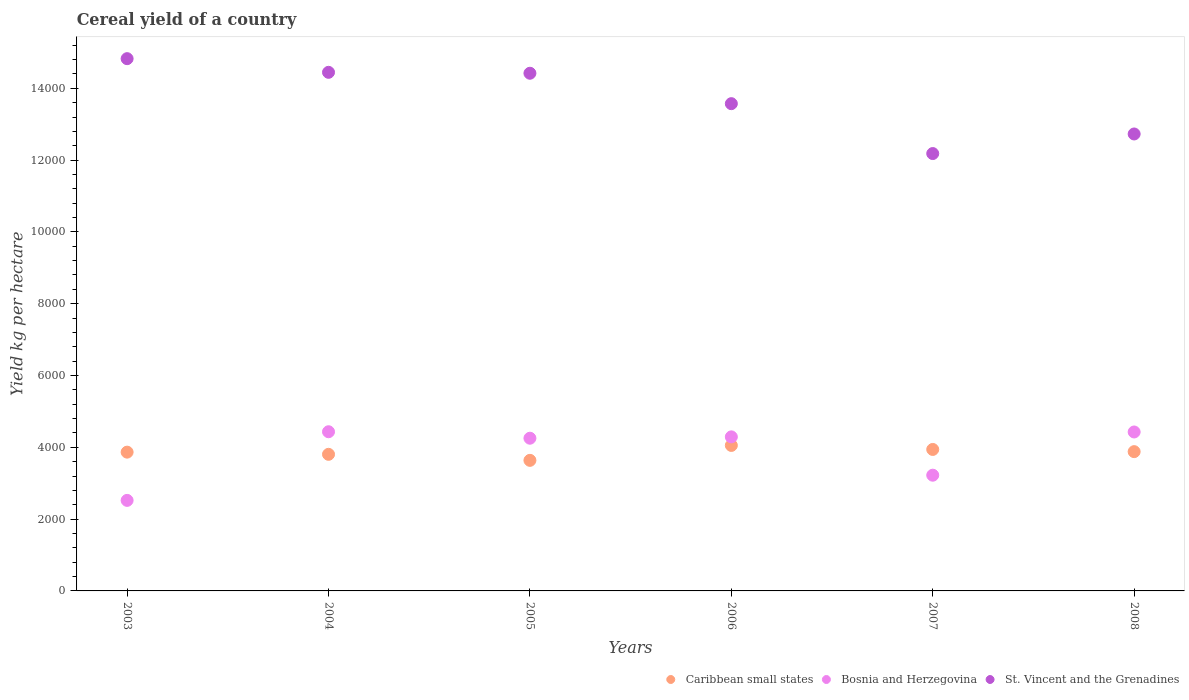How many different coloured dotlines are there?
Give a very brief answer. 3. Is the number of dotlines equal to the number of legend labels?
Make the answer very short. Yes. What is the total cereal yield in Bosnia and Herzegovina in 2006?
Ensure brevity in your answer.  4290.81. Across all years, what is the maximum total cereal yield in Bosnia and Herzegovina?
Your response must be concise. 4433.55. Across all years, what is the minimum total cereal yield in St. Vincent and the Grenadines?
Ensure brevity in your answer.  1.22e+04. In which year was the total cereal yield in St. Vincent and the Grenadines maximum?
Your response must be concise. 2003. In which year was the total cereal yield in St. Vincent and the Grenadines minimum?
Make the answer very short. 2007. What is the total total cereal yield in Caribbean small states in the graph?
Keep it short and to the point. 2.32e+04. What is the difference between the total cereal yield in Caribbean small states in 2005 and that in 2006?
Your response must be concise. -415.91. What is the difference between the total cereal yield in Bosnia and Herzegovina in 2006 and the total cereal yield in St. Vincent and the Grenadines in 2004?
Offer a very short reply. -1.02e+04. What is the average total cereal yield in St. Vincent and the Grenadines per year?
Provide a succinct answer. 1.37e+04. In the year 2003, what is the difference between the total cereal yield in Bosnia and Herzegovina and total cereal yield in St. Vincent and the Grenadines?
Offer a terse response. -1.23e+04. What is the ratio of the total cereal yield in Bosnia and Herzegovina in 2003 to that in 2006?
Your answer should be compact. 0.59. Is the total cereal yield in Bosnia and Herzegovina in 2007 less than that in 2008?
Make the answer very short. Yes. Is the difference between the total cereal yield in Bosnia and Herzegovina in 2005 and 2008 greater than the difference between the total cereal yield in St. Vincent and the Grenadines in 2005 and 2008?
Your answer should be very brief. No. What is the difference between the highest and the second highest total cereal yield in St. Vincent and the Grenadines?
Offer a terse response. 380.56. What is the difference between the highest and the lowest total cereal yield in Bosnia and Herzegovina?
Provide a succinct answer. 1911.92. In how many years, is the total cereal yield in Caribbean small states greater than the average total cereal yield in Caribbean small states taken over all years?
Provide a short and direct response. 4. Is the total cereal yield in Bosnia and Herzegovina strictly less than the total cereal yield in Caribbean small states over the years?
Your answer should be compact. No. How many dotlines are there?
Your response must be concise. 3. How many years are there in the graph?
Provide a succinct answer. 6. Does the graph contain grids?
Offer a very short reply. No. How are the legend labels stacked?
Your response must be concise. Horizontal. What is the title of the graph?
Your answer should be compact. Cereal yield of a country. What is the label or title of the Y-axis?
Offer a very short reply. Yield kg per hectare. What is the Yield kg per hectare of Caribbean small states in 2003?
Make the answer very short. 3865.45. What is the Yield kg per hectare in Bosnia and Herzegovina in 2003?
Provide a short and direct response. 2521.63. What is the Yield kg per hectare in St. Vincent and the Grenadines in 2003?
Your answer should be very brief. 1.48e+04. What is the Yield kg per hectare of Caribbean small states in 2004?
Provide a short and direct response. 3804.68. What is the Yield kg per hectare in Bosnia and Herzegovina in 2004?
Keep it short and to the point. 4433.55. What is the Yield kg per hectare of St. Vincent and the Grenadines in 2004?
Provide a succinct answer. 1.44e+04. What is the Yield kg per hectare of Caribbean small states in 2005?
Give a very brief answer. 3636.67. What is the Yield kg per hectare in Bosnia and Herzegovina in 2005?
Provide a short and direct response. 4253.26. What is the Yield kg per hectare in St. Vincent and the Grenadines in 2005?
Your answer should be very brief. 1.44e+04. What is the Yield kg per hectare in Caribbean small states in 2006?
Offer a terse response. 4052.57. What is the Yield kg per hectare in Bosnia and Herzegovina in 2006?
Your answer should be very brief. 4290.81. What is the Yield kg per hectare in St. Vincent and the Grenadines in 2006?
Give a very brief answer. 1.36e+04. What is the Yield kg per hectare of Caribbean small states in 2007?
Offer a terse response. 3940.38. What is the Yield kg per hectare of Bosnia and Herzegovina in 2007?
Your response must be concise. 3223.22. What is the Yield kg per hectare of St. Vincent and the Grenadines in 2007?
Offer a very short reply. 1.22e+04. What is the Yield kg per hectare in Caribbean small states in 2008?
Give a very brief answer. 3879.35. What is the Yield kg per hectare in Bosnia and Herzegovina in 2008?
Ensure brevity in your answer.  4427.09. What is the Yield kg per hectare of St. Vincent and the Grenadines in 2008?
Give a very brief answer. 1.27e+04. Across all years, what is the maximum Yield kg per hectare of Caribbean small states?
Your answer should be very brief. 4052.57. Across all years, what is the maximum Yield kg per hectare in Bosnia and Herzegovina?
Your response must be concise. 4433.55. Across all years, what is the maximum Yield kg per hectare of St. Vincent and the Grenadines?
Ensure brevity in your answer.  1.48e+04. Across all years, what is the minimum Yield kg per hectare of Caribbean small states?
Ensure brevity in your answer.  3636.67. Across all years, what is the minimum Yield kg per hectare of Bosnia and Herzegovina?
Provide a short and direct response. 2521.63. Across all years, what is the minimum Yield kg per hectare in St. Vincent and the Grenadines?
Make the answer very short. 1.22e+04. What is the total Yield kg per hectare in Caribbean small states in the graph?
Offer a terse response. 2.32e+04. What is the total Yield kg per hectare in Bosnia and Herzegovina in the graph?
Your answer should be compact. 2.31e+04. What is the total Yield kg per hectare of St. Vincent and the Grenadines in the graph?
Make the answer very short. 8.22e+04. What is the difference between the Yield kg per hectare in Caribbean small states in 2003 and that in 2004?
Give a very brief answer. 60.77. What is the difference between the Yield kg per hectare in Bosnia and Herzegovina in 2003 and that in 2004?
Make the answer very short. -1911.92. What is the difference between the Yield kg per hectare in St. Vincent and the Grenadines in 2003 and that in 2004?
Your response must be concise. 380.56. What is the difference between the Yield kg per hectare of Caribbean small states in 2003 and that in 2005?
Your response must be concise. 228.78. What is the difference between the Yield kg per hectare of Bosnia and Herzegovina in 2003 and that in 2005?
Your answer should be very brief. -1731.63. What is the difference between the Yield kg per hectare in St. Vincent and the Grenadines in 2003 and that in 2005?
Ensure brevity in your answer.  406.39. What is the difference between the Yield kg per hectare in Caribbean small states in 2003 and that in 2006?
Keep it short and to the point. -187.13. What is the difference between the Yield kg per hectare of Bosnia and Herzegovina in 2003 and that in 2006?
Keep it short and to the point. -1769.19. What is the difference between the Yield kg per hectare of St. Vincent and the Grenadines in 2003 and that in 2006?
Your answer should be very brief. 1253.57. What is the difference between the Yield kg per hectare in Caribbean small states in 2003 and that in 2007?
Give a very brief answer. -74.93. What is the difference between the Yield kg per hectare of Bosnia and Herzegovina in 2003 and that in 2007?
Give a very brief answer. -701.6. What is the difference between the Yield kg per hectare in St. Vincent and the Grenadines in 2003 and that in 2007?
Your response must be concise. 2643.18. What is the difference between the Yield kg per hectare in Caribbean small states in 2003 and that in 2008?
Keep it short and to the point. -13.91. What is the difference between the Yield kg per hectare in Bosnia and Herzegovina in 2003 and that in 2008?
Offer a terse response. -1905.47. What is the difference between the Yield kg per hectare of St. Vincent and the Grenadines in 2003 and that in 2008?
Your response must be concise. 2097.73. What is the difference between the Yield kg per hectare in Caribbean small states in 2004 and that in 2005?
Your answer should be compact. 168.01. What is the difference between the Yield kg per hectare of Bosnia and Herzegovina in 2004 and that in 2005?
Provide a succinct answer. 180.29. What is the difference between the Yield kg per hectare in St. Vincent and the Grenadines in 2004 and that in 2005?
Make the answer very short. 25.84. What is the difference between the Yield kg per hectare in Caribbean small states in 2004 and that in 2006?
Your response must be concise. -247.89. What is the difference between the Yield kg per hectare of Bosnia and Herzegovina in 2004 and that in 2006?
Your response must be concise. 142.74. What is the difference between the Yield kg per hectare of St. Vincent and the Grenadines in 2004 and that in 2006?
Keep it short and to the point. 873.01. What is the difference between the Yield kg per hectare of Caribbean small states in 2004 and that in 2007?
Offer a terse response. -135.7. What is the difference between the Yield kg per hectare in Bosnia and Herzegovina in 2004 and that in 2007?
Provide a short and direct response. 1210.32. What is the difference between the Yield kg per hectare of St. Vincent and the Grenadines in 2004 and that in 2007?
Your answer should be very brief. 2262.63. What is the difference between the Yield kg per hectare of Caribbean small states in 2004 and that in 2008?
Provide a short and direct response. -74.67. What is the difference between the Yield kg per hectare of Bosnia and Herzegovina in 2004 and that in 2008?
Provide a succinct answer. 6.46. What is the difference between the Yield kg per hectare in St. Vincent and the Grenadines in 2004 and that in 2008?
Give a very brief answer. 1717.17. What is the difference between the Yield kg per hectare in Caribbean small states in 2005 and that in 2006?
Give a very brief answer. -415.91. What is the difference between the Yield kg per hectare in Bosnia and Herzegovina in 2005 and that in 2006?
Give a very brief answer. -37.55. What is the difference between the Yield kg per hectare in St. Vincent and the Grenadines in 2005 and that in 2006?
Offer a very short reply. 847.18. What is the difference between the Yield kg per hectare in Caribbean small states in 2005 and that in 2007?
Provide a short and direct response. -303.71. What is the difference between the Yield kg per hectare of Bosnia and Herzegovina in 2005 and that in 2007?
Ensure brevity in your answer.  1030.04. What is the difference between the Yield kg per hectare of St. Vincent and the Grenadines in 2005 and that in 2007?
Offer a very short reply. 2236.79. What is the difference between the Yield kg per hectare of Caribbean small states in 2005 and that in 2008?
Your answer should be compact. -242.69. What is the difference between the Yield kg per hectare in Bosnia and Herzegovina in 2005 and that in 2008?
Your response must be concise. -173.83. What is the difference between the Yield kg per hectare in St. Vincent and the Grenadines in 2005 and that in 2008?
Provide a short and direct response. 1691.33. What is the difference between the Yield kg per hectare in Caribbean small states in 2006 and that in 2007?
Make the answer very short. 112.2. What is the difference between the Yield kg per hectare of Bosnia and Herzegovina in 2006 and that in 2007?
Offer a terse response. 1067.59. What is the difference between the Yield kg per hectare of St. Vincent and the Grenadines in 2006 and that in 2007?
Provide a short and direct response. 1389.61. What is the difference between the Yield kg per hectare in Caribbean small states in 2006 and that in 2008?
Give a very brief answer. 173.22. What is the difference between the Yield kg per hectare in Bosnia and Herzegovina in 2006 and that in 2008?
Offer a very short reply. -136.28. What is the difference between the Yield kg per hectare of St. Vincent and the Grenadines in 2006 and that in 2008?
Give a very brief answer. 844.16. What is the difference between the Yield kg per hectare in Caribbean small states in 2007 and that in 2008?
Provide a succinct answer. 61.02. What is the difference between the Yield kg per hectare in Bosnia and Herzegovina in 2007 and that in 2008?
Give a very brief answer. -1203.87. What is the difference between the Yield kg per hectare of St. Vincent and the Grenadines in 2007 and that in 2008?
Provide a succinct answer. -545.46. What is the difference between the Yield kg per hectare in Caribbean small states in 2003 and the Yield kg per hectare in Bosnia and Herzegovina in 2004?
Ensure brevity in your answer.  -568.1. What is the difference between the Yield kg per hectare of Caribbean small states in 2003 and the Yield kg per hectare of St. Vincent and the Grenadines in 2004?
Offer a very short reply. -1.06e+04. What is the difference between the Yield kg per hectare of Bosnia and Herzegovina in 2003 and the Yield kg per hectare of St. Vincent and the Grenadines in 2004?
Give a very brief answer. -1.19e+04. What is the difference between the Yield kg per hectare in Caribbean small states in 2003 and the Yield kg per hectare in Bosnia and Herzegovina in 2005?
Your response must be concise. -387.81. What is the difference between the Yield kg per hectare of Caribbean small states in 2003 and the Yield kg per hectare of St. Vincent and the Grenadines in 2005?
Ensure brevity in your answer.  -1.06e+04. What is the difference between the Yield kg per hectare of Bosnia and Herzegovina in 2003 and the Yield kg per hectare of St. Vincent and the Grenadines in 2005?
Offer a terse response. -1.19e+04. What is the difference between the Yield kg per hectare in Caribbean small states in 2003 and the Yield kg per hectare in Bosnia and Herzegovina in 2006?
Make the answer very short. -425.37. What is the difference between the Yield kg per hectare in Caribbean small states in 2003 and the Yield kg per hectare in St. Vincent and the Grenadines in 2006?
Keep it short and to the point. -9705.98. What is the difference between the Yield kg per hectare in Bosnia and Herzegovina in 2003 and the Yield kg per hectare in St. Vincent and the Grenadines in 2006?
Provide a succinct answer. -1.10e+04. What is the difference between the Yield kg per hectare in Caribbean small states in 2003 and the Yield kg per hectare in Bosnia and Herzegovina in 2007?
Provide a short and direct response. 642.22. What is the difference between the Yield kg per hectare of Caribbean small states in 2003 and the Yield kg per hectare of St. Vincent and the Grenadines in 2007?
Your answer should be compact. -8316.37. What is the difference between the Yield kg per hectare in Bosnia and Herzegovina in 2003 and the Yield kg per hectare in St. Vincent and the Grenadines in 2007?
Your answer should be compact. -9660.19. What is the difference between the Yield kg per hectare of Caribbean small states in 2003 and the Yield kg per hectare of Bosnia and Herzegovina in 2008?
Offer a terse response. -561.65. What is the difference between the Yield kg per hectare of Caribbean small states in 2003 and the Yield kg per hectare of St. Vincent and the Grenadines in 2008?
Offer a very short reply. -8861.83. What is the difference between the Yield kg per hectare in Bosnia and Herzegovina in 2003 and the Yield kg per hectare in St. Vincent and the Grenadines in 2008?
Make the answer very short. -1.02e+04. What is the difference between the Yield kg per hectare of Caribbean small states in 2004 and the Yield kg per hectare of Bosnia and Herzegovina in 2005?
Keep it short and to the point. -448.58. What is the difference between the Yield kg per hectare in Caribbean small states in 2004 and the Yield kg per hectare in St. Vincent and the Grenadines in 2005?
Ensure brevity in your answer.  -1.06e+04. What is the difference between the Yield kg per hectare of Bosnia and Herzegovina in 2004 and the Yield kg per hectare of St. Vincent and the Grenadines in 2005?
Your answer should be very brief. -9985.06. What is the difference between the Yield kg per hectare of Caribbean small states in 2004 and the Yield kg per hectare of Bosnia and Herzegovina in 2006?
Keep it short and to the point. -486.13. What is the difference between the Yield kg per hectare of Caribbean small states in 2004 and the Yield kg per hectare of St. Vincent and the Grenadines in 2006?
Your answer should be very brief. -9766.75. What is the difference between the Yield kg per hectare in Bosnia and Herzegovina in 2004 and the Yield kg per hectare in St. Vincent and the Grenadines in 2006?
Keep it short and to the point. -9137.88. What is the difference between the Yield kg per hectare in Caribbean small states in 2004 and the Yield kg per hectare in Bosnia and Herzegovina in 2007?
Provide a succinct answer. 581.46. What is the difference between the Yield kg per hectare of Caribbean small states in 2004 and the Yield kg per hectare of St. Vincent and the Grenadines in 2007?
Your answer should be very brief. -8377.14. What is the difference between the Yield kg per hectare of Bosnia and Herzegovina in 2004 and the Yield kg per hectare of St. Vincent and the Grenadines in 2007?
Provide a succinct answer. -7748.27. What is the difference between the Yield kg per hectare of Caribbean small states in 2004 and the Yield kg per hectare of Bosnia and Herzegovina in 2008?
Keep it short and to the point. -622.41. What is the difference between the Yield kg per hectare of Caribbean small states in 2004 and the Yield kg per hectare of St. Vincent and the Grenadines in 2008?
Provide a succinct answer. -8922.59. What is the difference between the Yield kg per hectare of Bosnia and Herzegovina in 2004 and the Yield kg per hectare of St. Vincent and the Grenadines in 2008?
Provide a succinct answer. -8293.73. What is the difference between the Yield kg per hectare in Caribbean small states in 2005 and the Yield kg per hectare in Bosnia and Herzegovina in 2006?
Keep it short and to the point. -654.15. What is the difference between the Yield kg per hectare in Caribbean small states in 2005 and the Yield kg per hectare in St. Vincent and the Grenadines in 2006?
Your answer should be compact. -9934.76. What is the difference between the Yield kg per hectare in Bosnia and Herzegovina in 2005 and the Yield kg per hectare in St. Vincent and the Grenadines in 2006?
Your response must be concise. -9318.17. What is the difference between the Yield kg per hectare of Caribbean small states in 2005 and the Yield kg per hectare of Bosnia and Herzegovina in 2007?
Keep it short and to the point. 413.44. What is the difference between the Yield kg per hectare in Caribbean small states in 2005 and the Yield kg per hectare in St. Vincent and the Grenadines in 2007?
Offer a very short reply. -8545.15. What is the difference between the Yield kg per hectare of Bosnia and Herzegovina in 2005 and the Yield kg per hectare of St. Vincent and the Grenadines in 2007?
Provide a succinct answer. -7928.56. What is the difference between the Yield kg per hectare of Caribbean small states in 2005 and the Yield kg per hectare of Bosnia and Herzegovina in 2008?
Your answer should be compact. -790.43. What is the difference between the Yield kg per hectare of Caribbean small states in 2005 and the Yield kg per hectare of St. Vincent and the Grenadines in 2008?
Your answer should be compact. -9090.61. What is the difference between the Yield kg per hectare of Bosnia and Herzegovina in 2005 and the Yield kg per hectare of St. Vincent and the Grenadines in 2008?
Provide a short and direct response. -8474.01. What is the difference between the Yield kg per hectare of Caribbean small states in 2006 and the Yield kg per hectare of Bosnia and Herzegovina in 2007?
Give a very brief answer. 829.35. What is the difference between the Yield kg per hectare in Caribbean small states in 2006 and the Yield kg per hectare in St. Vincent and the Grenadines in 2007?
Give a very brief answer. -8129.24. What is the difference between the Yield kg per hectare of Bosnia and Herzegovina in 2006 and the Yield kg per hectare of St. Vincent and the Grenadines in 2007?
Provide a short and direct response. -7891.01. What is the difference between the Yield kg per hectare in Caribbean small states in 2006 and the Yield kg per hectare in Bosnia and Herzegovina in 2008?
Make the answer very short. -374.52. What is the difference between the Yield kg per hectare in Caribbean small states in 2006 and the Yield kg per hectare in St. Vincent and the Grenadines in 2008?
Provide a succinct answer. -8674.7. What is the difference between the Yield kg per hectare in Bosnia and Herzegovina in 2006 and the Yield kg per hectare in St. Vincent and the Grenadines in 2008?
Give a very brief answer. -8436.46. What is the difference between the Yield kg per hectare in Caribbean small states in 2007 and the Yield kg per hectare in Bosnia and Herzegovina in 2008?
Ensure brevity in your answer.  -486.71. What is the difference between the Yield kg per hectare in Caribbean small states in 2007 and the Yield kg per hectare in St. Vincent and the Grenadines in 2008?
Offer a very short reply. -8786.89. What is the difference between the Yield kg per hectare in Bosnia and Herzegovina in 2007 and the Yield kg per hectare in St. Vincent and the Grenadines in 2008?
Offer a very short reply. -9504.05. What is the average Yield kg per hectare of Caribbean small states per year?
Ensure brevity in your answer.  3863.18. What is the average Yield kg per hectare in Bosnia and Herzegovina per year?
Ensure brevity in your answer.  3858.26. What is the average Yield kg per hectare of St. Vincent and the Grenadines per year?
Your answer should be compact. 1.37e+04. In the year 2003, what is the difference between the Yield kg per hectare of Caribbean small states and Yield kg per hectare of Bosnia and Herzegovina?
Make the answer very short. 1343.82. In the year 2003, what is the difference between the Yield kg per hectare of Caribbean small states and Yield kg per hectare of St. Vincent and the Grenadines?
Provide a succinct answer. -1.10e+04. In the year 2003, what is the difference between the Yield kg per hectare in Bosnia and Herzegovina and Yield kg per hectare in St. Vincent and the Grenadines?
Your response must be concise. -1.23e+04. In the year 2004, what is the difference between the Yield kg per hectare in Caribbean small states and Yield kg per hectare in Bosnia and Herzegovina?
Keep it short and to the point. -628.87. In the year 2004, what is the difference between the Yield kg per hectare in Caribbean small states and Yield kg per hectare in St. Vincent and the Grenadines?
Ensure brevity in your answer.  -1.06e+04. In the year 2004, what is the difference between the Yield kg per hectare of Bosnia and Herzegovina and Yield kg per hectare of St. Vincent and the Grenadines?
Your response must be concise. -1.00e+04. In the year 2005, what is the difference between the Yield kg per hectare in Caribbean small states and Yield kg per hectare in Bosnia and Herzegovina?
Your response must be concise. -616.59. In the year 2005, what is the difference between the Yield kg per hectare in Caribbean small states and Yield kg per hectare in St. Vincent and the Grenadines?
Offer a very short reply. -1.08e+04. In the year 2005, what is the difference between the Yield kg per hectare of Bosnia and Herzegovina and Yield kg per hectare of St. Vincent and the Grenadines?
Provide a succinct answer. -1.02e+04. In the year 2006, what is the difference between the Yield kg per hectare of Caribbean small states and Yield kg per hectare of Bosnia and Herzegovina?
Offer a terse response. -238.24. In the year 2006, what is the difference between the Yield kg per hectare of Caribbean small states and Yield kg per hectare of St. Vincent and the Grenadines?
Your answer should be compact. -9518.85. In the year 2006, what is the difference between the Yield kg per hectare of Bosnia and Herzegovina and Yield kg per hectare of St. Vincent and the Grenadines?
Provide a short and direct response. -9280.62. In the year 2007, what is the difference between the Yield kg per hectare of Caribbean small states and Yield kg per hectare of Bosnia and Herzegovina?
Make the answer very short. 717.15. In the year 2007, what is the difference between the Yield kg per hectare in Caribbean small states and Yield kg per hectare in St. Vincent and the Grenadines?
Make the answer very short. -8241.44. In the year 2007, what is the difference between the Yield kg per hectare in Bosnia and Herzegovina and Yield kg per hectare in St. Vincent and the Grenadines?
Your answer should be very brief. -8958.59. In the year 2008, what is the difference between the Yield kg per hectare in Caribbean small states and Yield kg per hectare in Bosnia and Herzegovina?
Provide a succinct answer. -547.74. In the year 2008, what is the difference between the Yield kg per hectare in Caribbean small states and Yield kg per hectare in St. Vincent and the Grenadines?
Provide a short and direct response. -8847.92. In the year 2008, what is the difference between the Yield kg per hectare in Bosnia and Herzegovina and Yield kg per hectare in St. Vincent and the Grenadines?
Make the answer very short. -8300.18. What is the ratio of the Yield kg per hectare of Bosnia and Herzegovina in 2003 to that in 2004?
Provide a succinct answer. 0.57. What is the ratio of the Yield kg per hectare of St. Vincent and the Grenadines in 2003 to that in 2004?
Your answer should be compact. 1.03. What is the ratio of the Yield kg per hectare in Caribbean small states in 2003 to that in 2005?
Your answer should be very brief. 1.06. What is the ratio of the Yield kg per hectare in Bosnia and Herzegovina in 2003 to that in 2005?
Provide a succinct answer. 0.59. What is the ratio of the Yield kg per hectare of St. Vincent and the Grenadines in 2003 to that in 2005?
Your answer should be compact. 1.03. What is the ratio of the Yield kg per hectare in Caribbean small states in 2003 to that in 2006?
Give a very brief answer. 0.95. What is the ratio of the Yield kg per hectare of Bosnia and Herzegovina in 2003 to that in 2006?
Provide a short and direct response. 0.59. What is the ratio of the Yield kg per hectare of St. Vincent and the Grenadines in 2003 to that in 2006?
Provide a short and direct response. 1.09. What is the ratio of the Yield kg per hectare of Caribbean small states in 2003 to that in 2007?
Keep it short and to the point. 0.98. What is the ratio of the Yield kg per hectare in Bosnia and Herzegovina in 2003 to that in 2007?
Give a very brief answer. 0.78. What is the ratio of the Yield kg per hectare in St. Vincent and the Grenadines in 2003 to that in 2007?
Provide a short and direct response. 1.22. What is the ratio of the Yield kg per hectare of Bosnia and Herzegovina in 2003 to that in 2008?
Your answer should be very brief. 0.57. What is the ratio of the Yield kg per hectare of St. Vincent and the Grenadines in 2003 to that in 2008?
Provide a short and direct response. 1.16. What is the ratio of the Yield kg per hectare in Caribbean small states in 2004 to that in 2005?
Offer a terse response. 1.05. What is the ratio of the Yield kg per hectare of Bosnia and Herzegovina in 2004 to that in 2005?
Ensure brevity in your answer.  1.04. What is the ratio of the Yield kg per hectare in Caribbean small states in 2004 to that in 2006?
Offer a very short reply. 0.94. What is the ratio of the Yield kg per hectare of St. Vincent and the Grenadines in 2004 to that in 2006?
Offer a very short reply. 1.06. What is the ratio of the Yield kg per hectare of Caribbean small states in 2004 to that in 2007?
Your answer should be very brief. 0.97. What is the ratio of the Yield kg per hectare in Bosnia and Herzegovina in 2004 to that in 2007?
Keep it short and to the point. 1.38. What is the ratio of the Yield kg per hectare in St. Vincent and the Grenadines in 2004 to that in 2007?
Ensure brevity in your answer.  1.19. What is the ratio of the Yield kg per hectare in Caribbean small states in 2004 to that in 2008?
Offer a terse response. 0.98. What is the ratio of the Yield kg per hectare in St. Vincent and the Grenadines in 2004 to that in 2008?
Provide a succinct answer. 1.13. What is the ratio of the Yield kg per hectare of Caribbean small states in 2005 to that in 2006?
Provide a short and direct response. 0.9. What is the ratio of the Yield kg per hectare of St. Vincent and the Grenadines in 2005 to that in 2006?
Your response must be concise. 1.06. What is the ratio of the Yield kg per hectare in Caribbean small states in 2005 to that in 2007?
Provide a succinct answer. 0.92. What is the ratio of the Yield kg per hectare of Bosnia and Herzegovina in 2005 to that in 2007?
Your answer should be compact. 1.32. What is the ratio of the Yield kg per hectare of St. Vincent and the Grenadines in 2005 to that in 2007?
Make the answer very short. 1.18. What is the ratio of the Yield kg per hectare in Caribbean small states in 2005 to that in 2008?
Make the answer very short. 0.94. What is the ratio of the Yield kg per hectare of Bosnia and Herzegovina in 2005 to that in 2008?
Ensure brevity in your answer.  0.96. What is the ratio of the Yield kg per hectare in St. Vincent and the Grenadines in 2005 to that in 2008?
Provide a succinct answer. 1.13. What is the ratio of the Yield kg per hectare of Caribbean small states in 2006 to that in 2007?
Provide a short and direct response. 1.03. What is the ratio of the Yield kg per hectare in Bosnia and Herzegovina in 2006 to that in 2007?
Ensure brevity in your answer.  1.33. What is the ratio of the Yield kg per hectare in St. Vincent and the Grenadines in 2006 to that in 2007?
Provide a short and direct response. 1.11. What is the ratio of the Yield kg per hectare of Caribbean small states in 2006 to that in 2008?
Make the answer very short. 1.04. What is the ratio of the Yield kg per hectare of Bosnia and Herzegovina in 2006 to that in 2008?
Your response must be concise. 0.97. What is the ratio of the Yield kg per hectare in St. Vincent and the Grenadines in 2006 to that in 2008?
Keep it short and to the point. 1.07. What is the ratio of the Yield kg per hectare in Caribbean small states in 2007 to that in 2008?
Provide a succinct answer. 1.02. What is the ratio of the Yield kg per hectare of Bosnia and Herzegovina in 2007 to that in 2008?
Ensure brevity in your answer.  0.73. What is the ratio of the Yield kg per hectare of St. Vincent and the Grenadines in 2007 to that in 2008?
Offer a terse response. 0.96. What is the difference between the highest and the second highest Yield kg per hectare in Caribbean small states?
Make the answer very short. 112.2. What is the difference between the highest and the second highest Yield kg per hectare of Bosnia and Herzegovina?
Give a very brief answer. 6.46. What is the difference between the highest and the second highest Yield kg per hectare of St. Vincent and the Grenadines?
Ensure brevity in your answer.  380.56. What is the difference between the highest and the lowest Yield kg per hectare in Caribbean small states?
Your answer should be compact. 415.91. What is the difference between the highest and the lowest Yield kg per hectare of Bosnia and Herzegovina?
Ensure brevity in your answer.  1911.92. What is the difference between the highest and the lowest Yield kg per hectare in St. Vincent and the Grenadines?
Make the answer very short. 2643.18. 